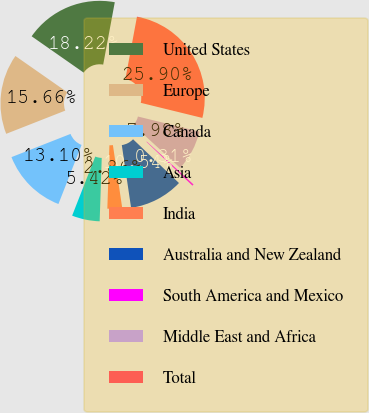Convert chart. <chart><loc_0><loc_0><loc_500><loc_500><pie_chart><fcel>United States<fcel>Europe<fcel>Canada<fcel>Asia<fcel>India<fcel>Australia and New Zealand<fcel>South America and Mexico<fcel>Middle East and Africa<fcel>Total<nl><fcel>18.22%<fcel>15.66%<fcel>13.1%<fcel>5.42%<fcel>2.86%<fcel>10.54%<fcel>0.31%<fcel>7.98%<fcel>25.9%<nl></chart> 